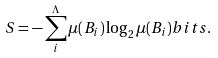<formula> <loc_0><loc_0><loc_500><loc_500>S = - \sum _ { i } ^ { \Lambda } { \mu } ( B _ { i } ) \log _ { 2 } \mu ( B _ { i } ) b i t s .</formula> 